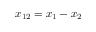Convert formula to latex. <formula><loc_0><loc_0><loc_500><loc_500>x _ { 1 2 } = x _ { 1 } - x _ { 2 }</formula> 